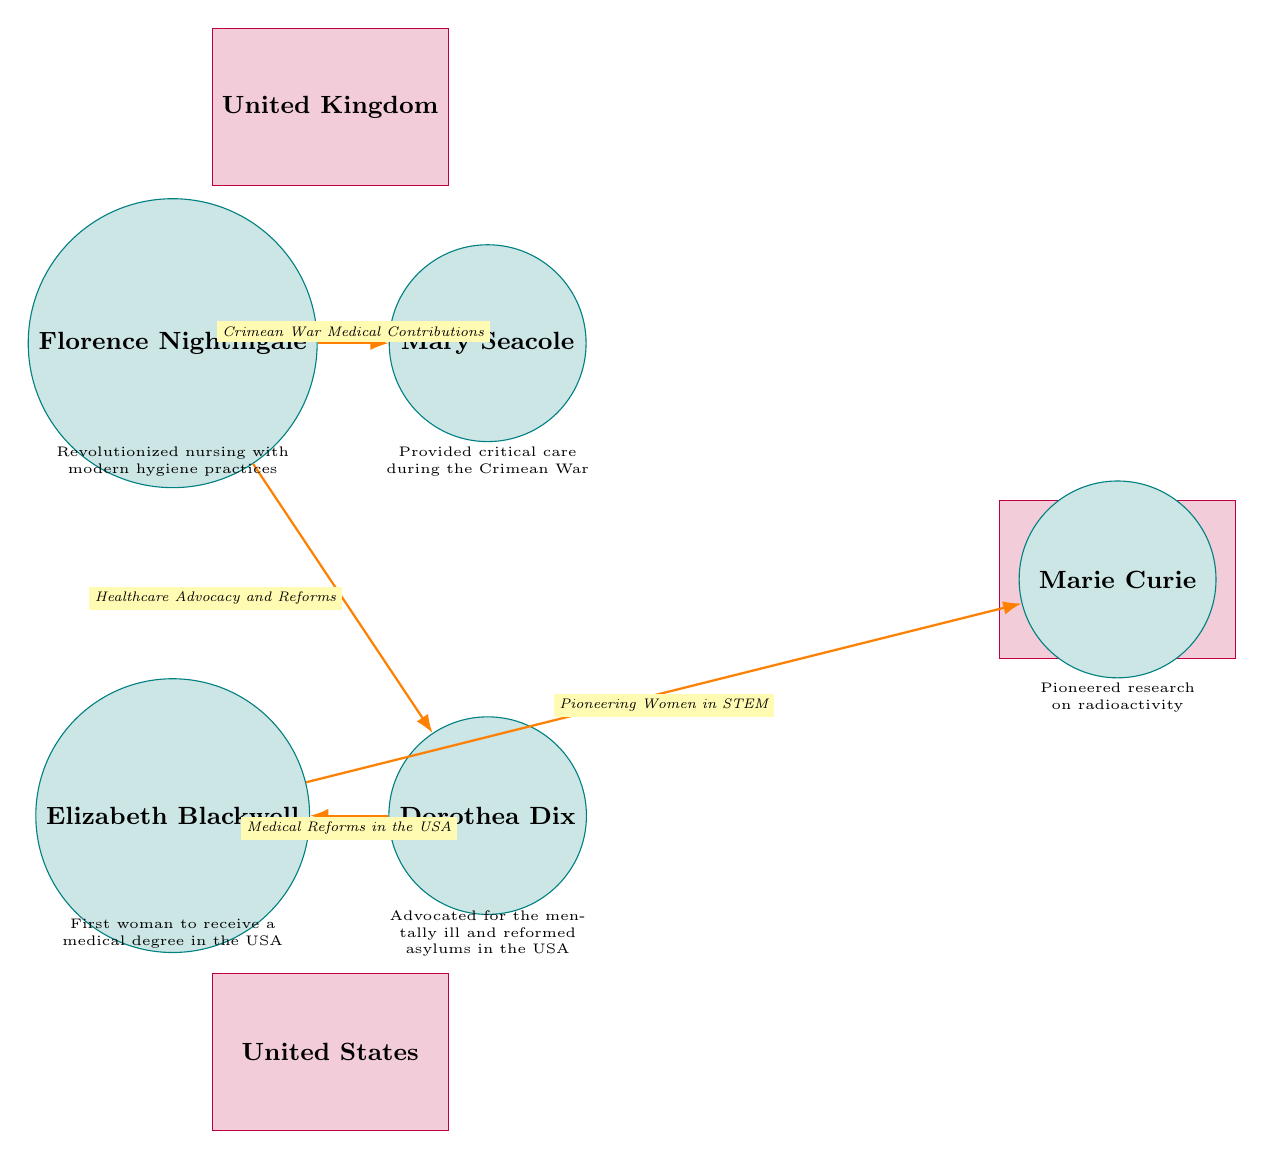What are the three locations represented in the diagram? The diagram shows three locations: the United Kingdom, the United States, and France. These are clearly labeled in rectangles at the top and bottom of the diagram, making them distinct locations for the depicted contributions.
Answer: United Kingdom, United States, France Who is associated with pioneering women in STEM? The diagram connects Elizabeth Blackwell and Marie Curie with the label "Pioneering Women in STEM." This shows the relationship between these two women based on their contributions in the sciences.
Answer: Elizabeth Blackwell, Marie Curie How many prominent women are depicted in the diagram? The diagram features five notable women: Florence Nightingale, Mary Seacole, Elizabeth Blackwell, Dorothea Dix, and Marie Curie. This count is based on the number of circles labeled with their names.
Answer: 5 What significant event is highlighted for Florence Nightingale and Mary Seacole? The connection between Florence Nightingale and Mary Seacole highlights their contributions during the Crimean War. This is indicated by the label placed on the arrow connecting these two individuals.
Answer: Crimean War Which two individuals focus on medical reforms in the USA? The diagram shows a connection between Elizabeth Blackwell and Dorothea Dix, highlighting their focus on medical reforms in the USA. This relationship is specified by the label on the connecting line.
Answer: Elizabeth Blackwell, Dorothea Dix Explain the relationship between Florence Nightingale and Dorothea Dix in the diagram. The diagram illustrates a relationship between Florence Nightingale and Dorothea Dix, denoted by the label "Healthcare Advocacy and Reforms." This indicates that both women contributed to the advancement of healthcare and reforms in their respective areas.
Answer: Healthcare Advocacy and Reforms What contribution did Marie Curie make, as noted in the diagram? The diagram notes that Marie Curie pioneered research on radioactivity. This is specified in a descriptive box next to her name, emphasizing her groundbreaking scientific contributions.
Answer: Research on radioactivity Which medical contribution is specified for Elizabeth Blackwell? The diagram specifies that Elizabeth Blackwell was the first woman to receive a medical degree in the USA. This significant achievement is detailed in the box next to her circle.
Answer: First woman to receive a medical degree in the USA 